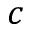Convert formula to latex. <formula><loc_0><loc_0><loc_500><loc_500>c</formula> 